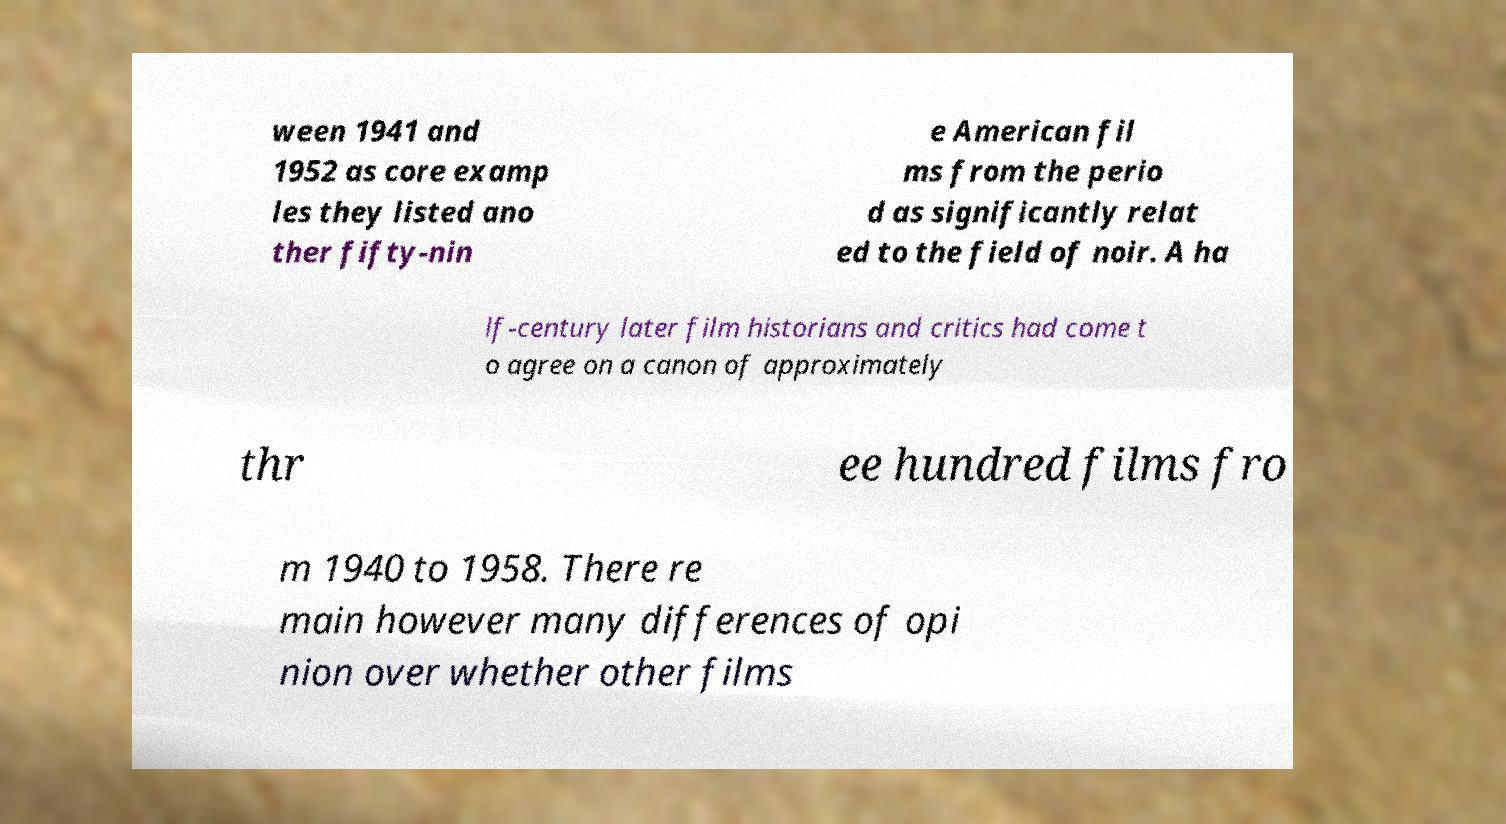Please identify and transcribe the text found in this image. ween 1941 and 1952 as core examp les they listed ano ther fifty-nin e American fil ms from the perio d as significantly relat ed to the field of noir. A ha lf-century later film historians and critics had come t o agree on a canon of approximately thr ee hundred films fro m 1940 to 1958. There re main however many differences of opi nion over whether other films 